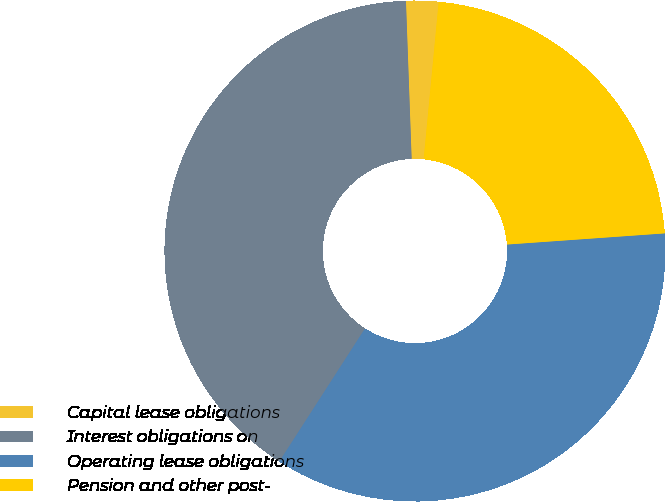Convert chart to OTSL. <chart><loc_0><loc_0><loc_500><loc_500><pie_chart><fcel>Capital lease obligations<fcel>Interest obligations on<fcel>Operating lease obligations<fcel>Pension and other post-<nl><fcel>2.09%<fcel>40.32%<fcel>35.23%<fcel>22.36%<nl></chart> 